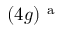<formula> <loc_0><loc_0><loc_500><loc_500>( 4 g ) ^ { a }</formula> 